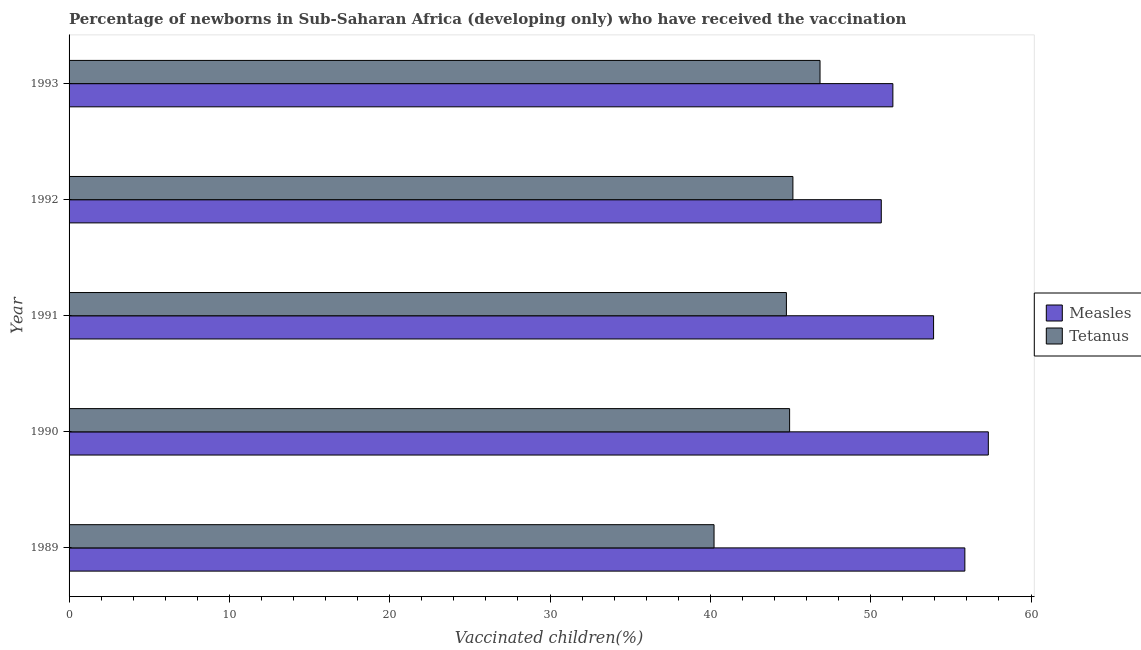How many different coloured bars are there?
Ensure brevity in your answer.  2. Are the number of bars per tick equal to the number of legend labels?
Your answer should be very brief. Yes. How many bars are there on the 1st tick from the bottom?
Keep it short and to the point. 2. In how many cases, is the number of bars for a given year not equal to the number of legend labels?
Offer a very short reply. 0. What is the percentage of newborns who received vaccination for tetanus in 1993?
Give a very brief answer. 46.84. Across all years, what is the maximum percentage of newborns who received vaccination for tetanus?
Your response must be concise. 46.84. Across all years, what is the minimum percentage of newborns who received vaccination for measles?
Offer a terse response. 50.66. In which year was the percentage of newborns who received vaccination for tetanus minimum?
Make the answer very short. 1989. What is the total percentage of newborns who received vaccination for tetanus in the graph?
Provide a short and direct response. 221.9. What is the difference between the percentage of newborns who received vaccination for measles in 1989 and that in 1991?
Give a very brief answer. 1.95. What is the difference between the percentage of newborns who received vaccination for measles in 1991 and the percentage of newborns who received vaccination for tetanus in 1992?
Offer a terse response. 8.77. What is the average percentage of newborns who received vaccination for tetanus per year?
Your answer should be compact. 44.38. In the year 1991, what is the difference between the percentage of newborns who received vaccination for tetanus and percentage of newborns who received vaccination for measles?
Make the answer very short. -9.18. In how many years, is the percentage of newborns who received vaccination for measles greater than 14 %?
Ensure brevity in your answer.  5. Is the percentage of newborns who received vaccination for measles in 1992 less than that in 1993?
Your response must be concise. Yes. What is the difference between the highest and the second highest percentage of newborns who received vaccination for tetanus?
Your answer should be very brief. 1.69. What is the difference between the highest and the lowest percentage of newborns who received vaccination for measles?
Your answer should be compact. 6.68. What does the 1st bar from the top in 1993 represents?
Your answer should be very brief. Tetanus. What does the 1st bar from the bottom in 1992 represents?
Provide a succinct answer. Measles. How many bars are there?
Your answer should be very brief. 10. How many years are there in the graph?
Ensure brevity in your answer.  5. What is the difference between two consecutive major ticks on the X-axis?
Provide a succinct answer. 10. Where does the legend appear in the graph?
Offer a terse response. Center right. How many legend labels are there?
Offer a very short reply. 2. How are the legend labels stacked?
Make the answer very short. Vertical. What is the title of the graph?
Provide a succinct answer. Percentage of newborns in Sub-Saharan Africa (developing only) who have received the vaccination. Does "Secondary" appear as one of the legend labels in the graph?
Offer a terse response. No. What is the label or title of the X-axis?
Your response must be concise. Vaccinated children(%)
. What is the label or title of the Y-axis?
Keep it short and to the point. Year. What is the Vaccinated children(%)
 of Measles in 1989?
Keep it short and to the point. 55.87. What is the Vaccinated children(%)
 of Tetanus in 1989?
Ensure brevity in your answer.  40.23. What is the Vaccinated children(%)
 in Measles in 1990?
Your answer should be very brief. 57.34. What is the Vaccinated children(%)
 in Tetanus in 1990?
Your answer should be very brief. 44.94. What is the Vaccinated children(%)
 of Measles in 1991?
Your answer should be very brief. 53.92. What is the Vaccinated children(%)
 of Tetanus in 1991?
Provide a short and direct response. 44.74. What is the Vaccinated children(%)
 of Measles in 1992?
Provide a short and direct response. 50.66. What is the Vaccinated children(%)
 in Tetanus in 1992?
Provide a succinct answer. 45.15. What is the Vaccinated children(%)
 of Measles in 1993?
Make the answer very short. 51.38. What is the Vaccinated children(%)
 of Tetanus in 1993?
Your answer should be very brief. 46.84. Across all years, what is the maximum Vaccinated children(%)
 in Measles?
Your answer should be very brief. 57.34. Across all years, what is the maximum Vaccinated children(%)
 of Tetanus?
Your response must be concise. 46.84. Across all years, what is the minimum Vaccinated children(%)
 of Measles?
Keep it short and to the point. 50.66. Across all years, what is the minimum Vaccinated children(%)
 of Tetanus?
Your answer should be very brief. 40.23. What is the total Vaccinated children(%)
 in Measles in the graph?
Your answer should be compact. 269.17. What is the total Vaccinated children(%)
 of Tetanus in the graph?
Make the answer very short. 221.9. What is the difference between the Vaccinated children(%)
 of Measles in 1989 and that in 1990?
Make the answer very short. -1.46. What is the difference between the Vaccinated children(%)
 of Tetanus in 1989 and that in 1990?
Your answer should be compact. -4.71. What is the difference between the Vaccinated children(%)
 of Measles in 1989 and that in 1991?
Provide a short and direct response. 1.95. What is the difference between the Vaccinated children(%)
 of Tetanus in 1989 and that in 1991?
Offer a terse response. -4.51. What is the difference between the Vaccinated children(%)
 of Measles in 1989 and that in 1992?
Provide a short and direct response. 5.21. What is the difference between the Vaccinated children(%)
 of Tetanus in 1989 and that in 1992?
Your response must be concise. -4.92. What is the difference between the Vaccinated children(%)
 of Measles in 1989 and that in 1993?
Your answer should be very brief. 4.49. What is the difference between the Vaccinated children(%)
 in Tetanus in 1989 and that in 1993?
Ensure brevity in your answer.  -6.61. What is the difference between the Vaccinated children(%)
 of Measles in 1990 and that in 1991?
Offer a very short reply. 3.41. What is the difference between the Vaccinated children(%)
 of Tetanus in 1990 and that in 1991?
Offer a terse response. 0.2. What is the difference between the Vaccinated children(%)
 in Measles in 1990 and that in 1992?
Keep it short and to the point. 6.68. What is the difference between the Vaccinated children(%)
 of Tetanus in 1990 and that in 1992?
Provide a short and direct response. -0.21. What is the difference between the Vaccinated children(%)
 in Measles in 1990 and that in 1993?
Give a very brief answer. 5.95. What is the difference between the Vaccinated children(%)
 of Tetanus in 1990 and that in 1993?
Provide a succinct answer. -1.9. What is the difference between the Vaccinated children(%)
 in Measles in 1991 and that in 1992?
Ensure brevity in your answer.  3.26. What is the difference between the Vaccinated children(%)
 of Tetanus in 1991 and that in 1992?
Offer a very short reply. -0.4. What is the difference between the Vaccinated children(%)
 in Measles in 1991 and that in 1993?
Make the answer very short. 2.54. What is the difference between the Vaccinated children(%)
 of Tetanus in 1991 and that in 1993?
Offer a terse response. -2.1. What is the difference between the Vaccinated children(%)
 in Measles in 1992 and that in 1993?
Your answer should be very brief. -0.72. What is the difference between the Vaccinated children(%)
 in Tetanus in 1992 and that in 1993?
Your response must be concise. -1.69. What is the difference between the Vaccinated children(%)
 in Measles in 1989 and the Vaccinated children(%)
 in Tetanus in 1990?
Give a very brief answer. 10.93. What is the difference between the Vaccinated children(%)
 in Measles in 1989 and the Vaccinated children(%)
 in Tetanus in 1991?
Your answer should be compact. 11.13. What is the difference between the Vaccinated children(%)
 of Measles in 1989 and the Vaccinated children(%)
 of Tetanus in 1992?
Ensure brevity in your answer.  10.73. What is the difference between the Vaccinated children(%)
 of Measles in 1989 and the Vaccinated children(%)
 of Tetanus in 1993?
Give a very brief answer. 9.03. What is the difference between the Vaccinated children(%)
 in Measles in 1990 and the Vaccinated children(%)
 in Tetanus in 1991?
Your answer should be very brief. 12.59. What is the difference between the Vaccinated children(%)
 in Measles in 1990 and the Vaccinated children(%)
 in Tetanus in 1992?
Ensure brevity in your answer.  12.19. What is the difference between the Vaccinated children(%)
 of Measles in 1990 and the Vaccinated children(%)
 of Tetanus in 1993?
Your answer should be very brief. 10.5. What is the difference between the Vaccinated children(%)
 of Measles in 1991 and the Vaccinated children(%)
 of Tetanus in 1992?
Give a very brief answer. 8.77. What is the difference between the Vaccinated children(%)
 in Measles in 1991 and the Vaccinated children(%)
 in Tetanus in 1993?
Ensure brevity in your answer.  7.08. What is the difference between the Vaccinated children(%)
 in Measles in 1992 and the Vaccinated children(%)
 in Tetanus in 1993?
Provide a succinct answer. 3.82. What is the average Vaccinated children(%)
 in Measles per year?
Provide a succinct answer. 53.83. What is the average Vaccinated children(%)
 in Tetanus per year?
Offer a terse response. 44.38. In the year 1989, what is the difference between the Vaccinated children(%)
 in Measles and Vaccinated children(%)
 in Tetanus?
Give a very brief answer. 15.64. In the year 1990, what is the difference between the Vaccinated children(%)
 of Measles and Vaccinated children(%)
 of Tetanus?
Offer a terse response. 12.39. In the year 1991, what is the difference between the Vaccinated children(%)
 of Measles and Vaccinated children(%)
 of Tetanus?
Your response must be concise. 9.18. In the year 1992, what is the difference between the Vaccinated children(%)
 in Measles and Vaccinated children(%)
 in Tetanus?
Your response must be concise. 5.51. In the year 1993, what is the difference between the Vaccinated children(%)
 in Measles and Vaccinated children(%)
 in Tetanus?
Your answer should be compact. 4.54. What is the ratio of the Vaccinated children(%)
 in Measles in 1989 to that in 1990?
Provide a succinct answer. 0.97. What is the ratio of the Vaccinated children(%)
 of Tetanus in 1989 to that in 1990?
Offer a terse response. 0.9. What is the ratio of the Vaccinated children(%)
 of Measles in 1989 to that in 1991?
Give a very brief answer. 1.04. What is the ratio of the Vaccinated children(%)
 in Tetanus in 1989 to that in 1991?
Your response must be concise. 0.9. What is the ratio of the Vaccinated children(%)
 of Measles in 1989 to that in 1992?
Your answer should be compact. 1.1. What is the ratio of the Vaccinated children(%)
 in Tetanus in 1989 to that in 1992?
Give a very brief answer. 0.89. What is the ratio of the Vaccinated children(%)
 in Measles in 1989 to that in 1993?
Your answer should be compact. 1.09. What is the ratio of the Vaccinated children(%)
 of Tetanus in 1989 to that in 1993?
Give a very brief answer. 0.86. What is the ratio of the Vaccinated children(%)
 of Measles in 1990 to that in 1991?
Offer a terse response. 1.06. What is the ratio of the Vaccinated children(%)
 in Tetanus in 1990 to that in 1991?
Ensure brevity in your answer.  1. What is the ratio of the Vaccinated children(%)
 of Measles in 1990 to that in 1992?
Ensure brevity in your answer.  1.13. What is the ratio of the Vaccinated children(%)
 of Tetanus in 1990 to that in 1992?
Offer a terse response. 1. What is the ratio of the Vaccinated children(%)
 of Measles in 1990 to that in 1993?
Offer a very short reply. 1.12. What is the ratio of the Vaccinated children(%)
 of Tetanus in 1990 to that in 1993?
Ensure brevity in your answer.  0.96. What is the ratio of the Vaccinated children(%)
 in Measles in 1991 to that in 1992?
Give a very brief answer. 1.06. What is the ratio of the Vaccinated children(%)
 in Measles in 1991 to that in 1993?
Your response must be concise. 1.05. What is the ratio of the Vaccinated children(%)
 in Tetanus in 1991 to that in 1993?
Provide a short and direct response. 0.96. What is the ratio of the Vaccinated children(%)
 in Measles in 1992 to that in 1993?
Provide a succinct answer. 0.99. What is the ratio of the Vaccinated children(%)
 in Tetanus in 1992 to that in 1993?
Provide a succinct answer. 0.96. What is the difference between the highest and the second highest Vaccinated children(%)
 of Measles?
Keep it short and to the point. 1.46. What is the difference between the highest and the second highest Vaccinated children(%)
 of Tetanus?
Your answer should be compact. 1.69. What is the difference between the highest and the lowest Vaccinated children(%)
 in Measles?
Offer a terse response. 6.68. What is the difference between the highest and the lowest Vaccinated children(%)
 of Tetanus?
Offer a very short reply. 6.61. 